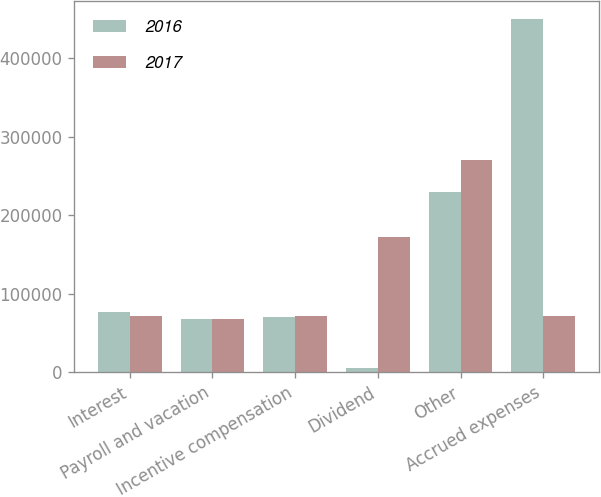Convert chart. <chart><loc_0><loc_0><loc_500><loc_500><stacked_bar_chart><ecel><fcel>Interest<fcel>Payroll and vacation<fcel>Incentive compensation<fcel>Dividend<fcel>Other<fcel>Accrued expenses<nl><fcel>2016<fcel>76615<fcel>68067<fcel>70117<fcel>5625<fcel>229833<fcel>450257<nl><fcel>2017<fcel>71176<fcel>67379<fcel>72006<fcel>172102<fcel>270483<fcel>72006<nl></chart> 